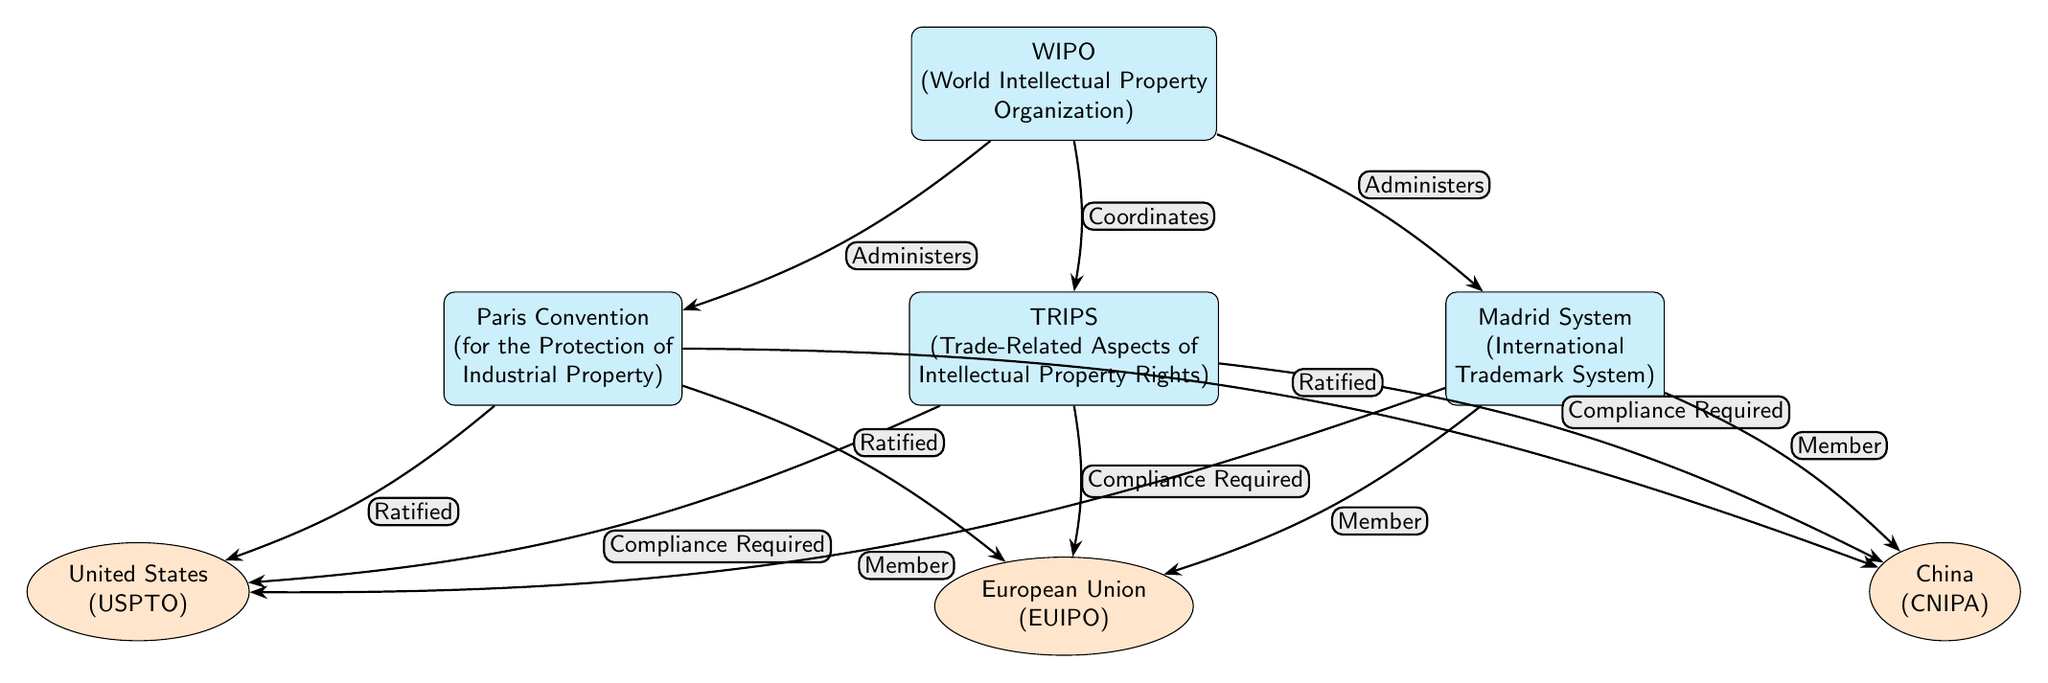What are the three treaties depicted in the diagram? The diagram shows three treaties: the WIPO, TRIPS, and Paris Convention. I can identify them based on their labeled nodes.
Answer: WIPO, TRIPS, Paris Convention How many countries are represented in the diagram? The diagram includes three countries: the United States, the European Union, and China. I counted the nodes labeled with a country.
Answer: 3 Which organization administers the Madrid System? The diagram indicates that WIPO administers the Madrid System as per the directed edge connecting WIPO to Madrid, labeled "Administers".
Answer: WIPO What type of compliance is required by the TRIPS Agreement for the three countries? The diagram specifies that compliance is required, as illustrated by the directed edges from TRIPS to each country, all labeled "Compliance Required".
Answer: Compliance Required Which treaty requires ratification by all three represented countries? The Paris Convention is shown to be ratified by the United States, European Union, and China, as indicated by the directed edges from Paris to each country, labeled "Ratified".
Answer: Paris Convention What is the relationship between the WIPO and the TRIPS Agreement in the diagram? The diagram illustrates that WIPO coordinates with TRIPS, as shown by the directed edge from WIPO to TRIPS labeled "Coordinates".
Answer: Coordinates How are the three countries related to the Madrid System? Each country is indicated to be a member of the Madrid System, as shown by the directed edges from Madrid to each country, all labeled "Member".
Answer: Member What does the label "Administers" tell us about WIPO regarding the treaties? The label "Administers" in the diagram indicates that WIPO is responsible for both the Paris Convention and the Madrid System, shown by the edges connecting WIPO to these treaties.
Answer: Administers When was the last treaty fully joined by all represented countries? This information isn't explicit in the diagram; therefore, I would infer it's necessary to access external resources for historical treaty joining dates.
Answer: Not displayed 